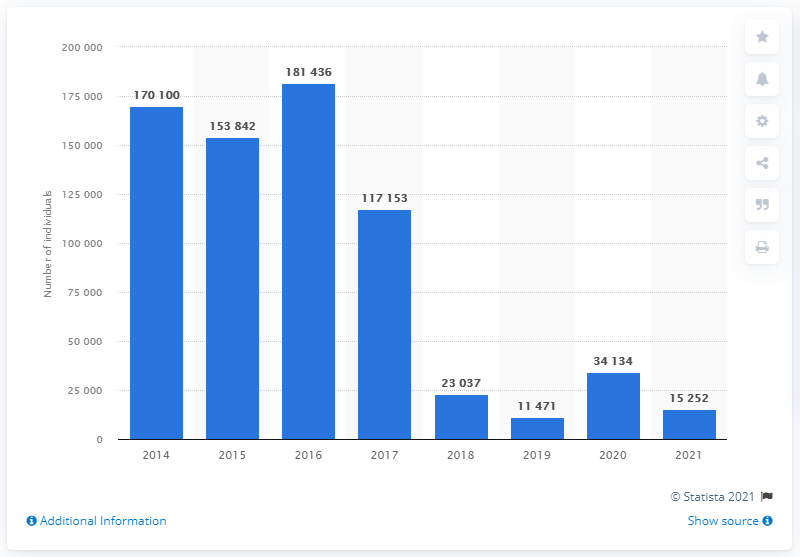Indicate a few pertinent items in this graphic. In 2020, a total of 34,134 migrants arrived on the Italian coasts. During the period of 2014 to 2020, a total of 18,1436 migrants arrived in Italy. 